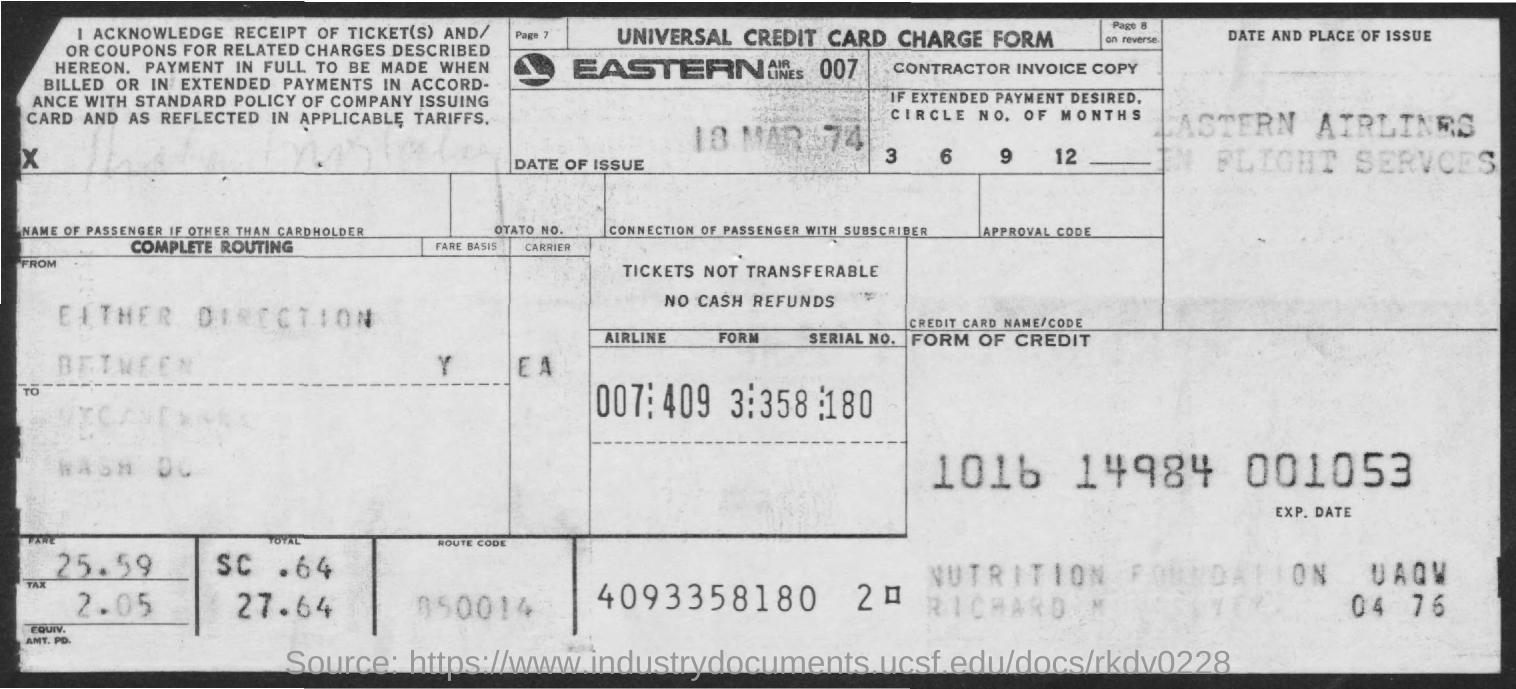What is the date of issue?
Make the answer very short. 18 mar 74. How much is the total fare including tax?
Offer a very short reply. 27.64. Which arilines name is on the stamp?
Ensure brevity in your answer.  Easter Airlines. What is the name of form given?
Provide a succinct answer. Universal credit card charge form. 